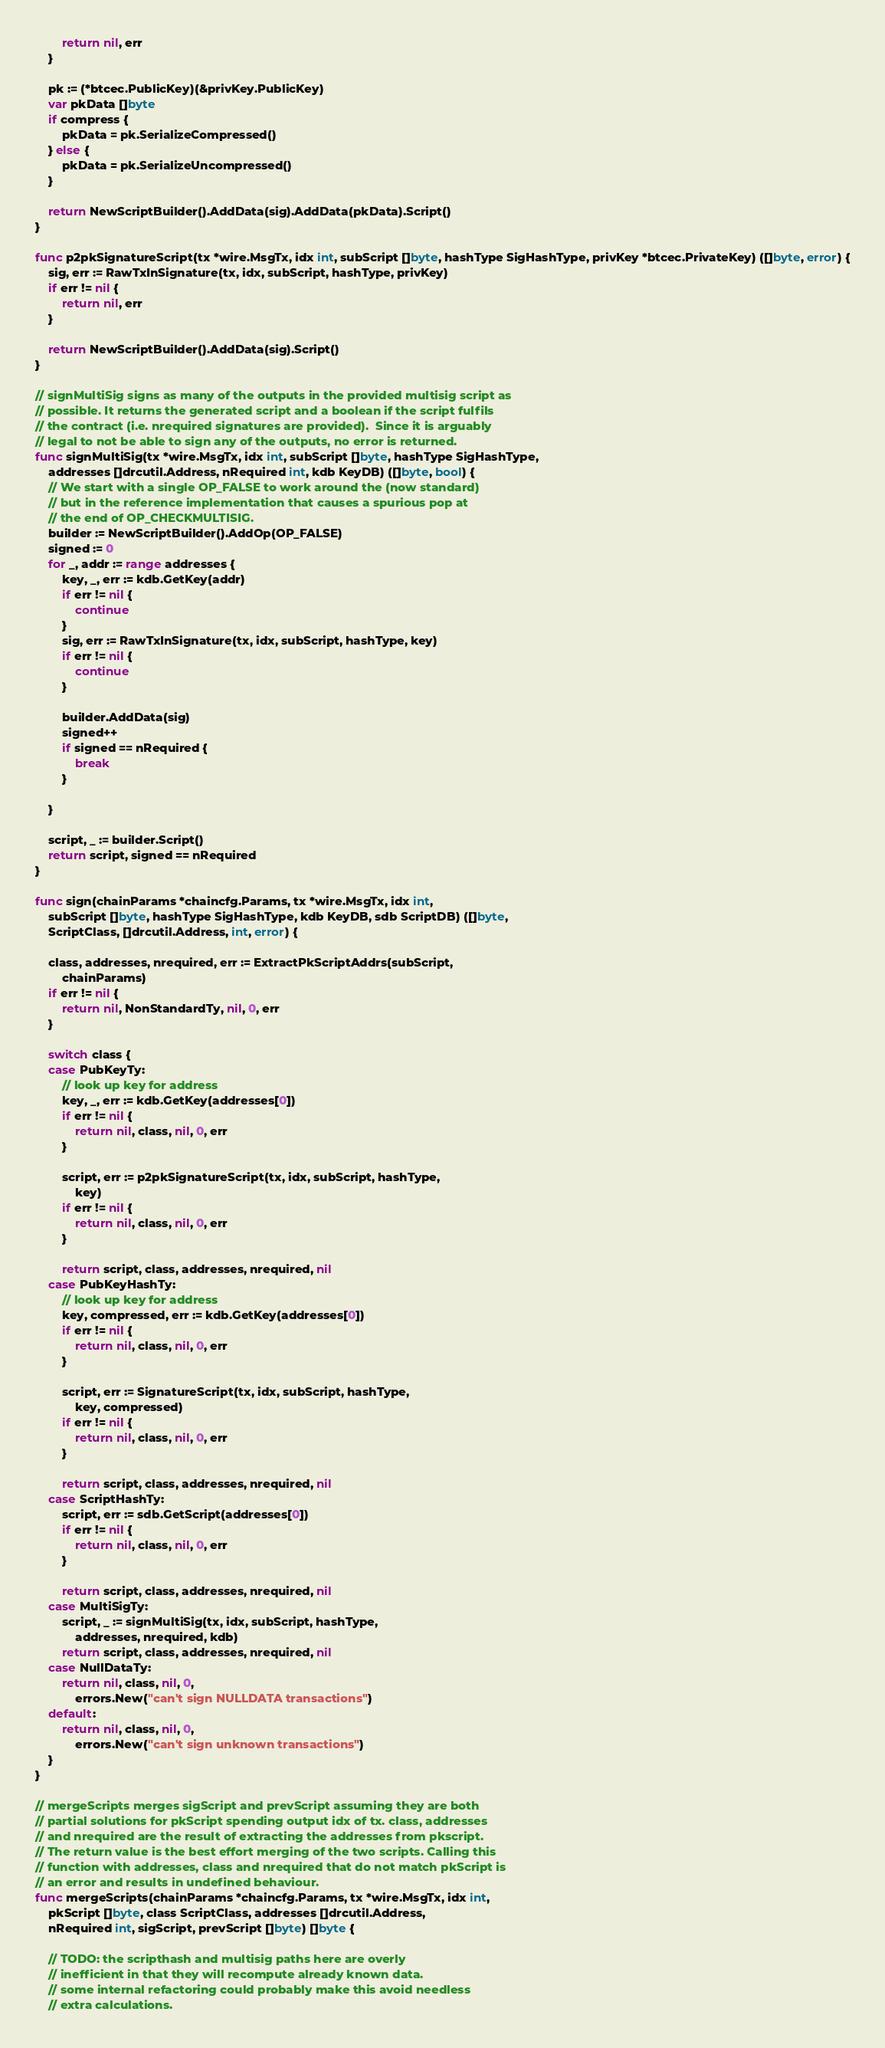<code> <loc_0><loc_0><loc_500><loc_500><_Go_>		return nil, err
	}

	pk := (*btcec.PublicKey)(&privKey.PublicKey)
	var pkData []byte
	if compress {
		pkData = pk.SerializeCompressed()
	} else {
		pkData = pk.SerializeUncompressed()
	}

	return NewScriptBuilder().AddData(sig).AddData(pkData).Script()
}

func p2pkSignatureScript(tx *wire.MsgTx, idx int, subScript []byte, hashType SigHashType, privKey *btcec.PrivateKey) ([]byte, error) {
	sig, err := RawTxInSignature(tx, idx, subScript, hashType, privKey)
	if err != nil {
		return nil, err
	}

	return NewScriptBuilder().AddData(sig).Script()
}

// signMultiSig signs as many of the outputs in the provided multisig script as
// possible. It returns the generated script and a boolean if the script fulfils
// the contract (i.e. nrequired signatures are provided).  Since it is arguably
// legal to not be able to sign any of the outputs, no error is returned.
func signMultiSig(tx *wire.MsgTx, idx int, subScript []byte, hashType SigHashType,
	addresses []drcutil.Address, nRequired int, kdb KeyDB) ([]byte, bool) {
	// We start with a single OP_FALSE to work around the (now standard)
	// but in the reference implementation that causes a spurious pop at
	// the end of OP_CHECKMULTISIG.
	builder := NewScriptBuilder().AddOp(OP_FALSE)
	signed := 0
	for _, addr := range addresses {
		key, _, err := kdb.GetKey(addr)
		if err != nil {
			continue
		}
		sig, err := RawTxInSignature(tx, idx, subScript, hashType, key)
		if err != nil {
			continue
		}

		builder.AddData(sig)
		signed++
		if signed == nRequired {
			break
		}

	}

	script, _ := builder.Script()
	return script, signed == nRequired
}

func sign(chainParams *chaincfg.Params, tx *wire.MsgTx, idx int,
	subScript []byte, hashType SigHashType, kdb KeyDB, sdb ScriptDB) ([]byte,
	ScriptClass, []drcutil.Address, int, error) {

	class, addresses, nrequired, err := ExtractPkScriptAddrs(subScript,
		chainParams)
	if err != nil {
		return nil, NonStandardTy, nil, 0, err
	}

	switch class {
	case PubKeyTy:
		// look up key for address
		key, _, err := kdb.GetKey(addresses[0])
		if err != nil {
			return nil, class, nil, 0, err
		}

		script, err := p2pkSignatureScript(tx, idx, subScript, hashType,
			key)
		if err != nil {
			return nil, class, nil, 0, err
		}

		return script, class, addresses, nrequired, nil
	case PubKeyHashTy:
		// look up key for address
		key, compressed, err := kdb.GetKey(addresses[0])
		if err != nil {
			return nil, class, nil, 0, err
		}

		script, err := SignatureScript(tx, idx, subScript, hashType,
			key, compressed)
		if err != nil {
			return nil, class, nil, 0, err
		}

		return script, class, addresses, nrequired, nil
	case ScriptHashTy:
		script, err := sdb.GetScript(addresses[0])
		if err != nil {
			return nil, class, nil, 0, err
		}

		return script, class, addresses, nrequired, nil
	case MultiSigTy:
		script, _ := signMultiSig(tx, idx, subScript, hashType,
			addresses, nrequired, kdb)
		return script, class, addresses, nrequired, nil
	case NullDataTy:
		return nil, class, nil, 0,
			errors.New("can't sign NULLDATA transactions")
	default:
		return nil, class, nil, 0,
			errors.New("can't sign unknown transactions")
	}
}

// mergeScripts merges sigScript and prevScript assuming they are both
// partial solutions for pkScript spending output idx of tx. class, addresses
// and nrequired are the result of extracting the addresses from pkscript.
// The return value is the best effort merging of the two scripts. Calling this
// function with addresses, class and nrequired that do not match pkScript is
// an error and results in undefined behaviour.
func mergeScripts(chainParams *chaincfg.Params, tx *wire.MsgTx, idx int,
	pkScript []byte, class ScriptClass, addresses []drcutil.Address,
	nRequired int, sigScript, prevScript []byte) []byte {

	// TODO: the scripthash and multisig paths here are overly
	// inefficient in that they will recompute already known data.
	// some internal refactoring could probably make this avoid needless
	// extra calculations.</code> 